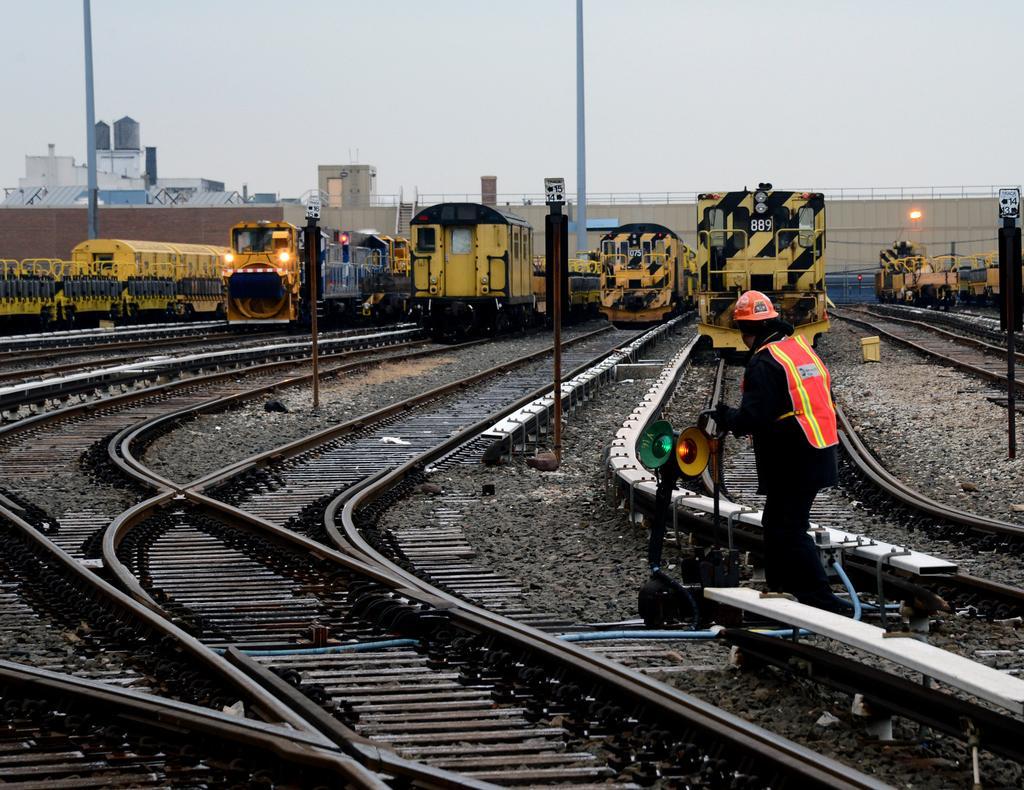Please provide a concise description of this image. In this picture there is a person and we can see object, trains, tracks and poles. In the background of the image we can see buildings, wall, fence and sky. 